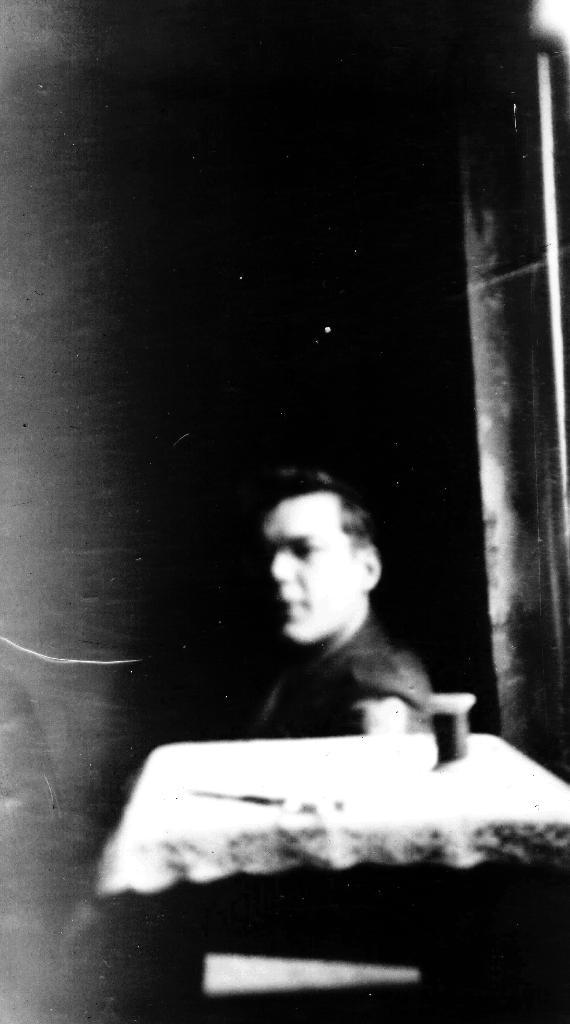Who or what is in the image? There is a person in the image. Where is the person located in relation to other objects? The person is beside a table. What can be found on the table in the image? There is an unspecified "thing" on the table. What type of arch can be seen in the image? There is no arch present in the image. What cast member is visible in the image? The image does not depict a cast member from a movie or TV show. 